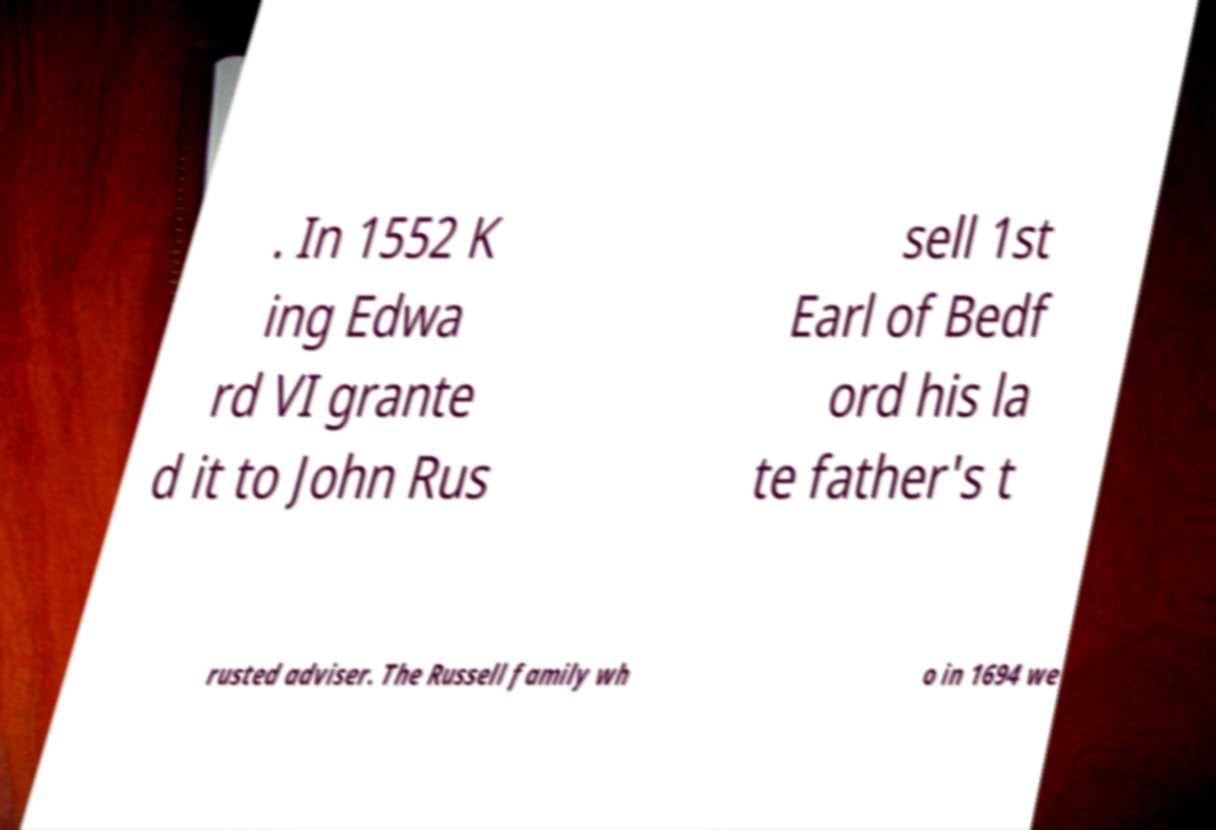Could you extract and type out the text from this image? . In 1552 K ing Edwa rd VI grante d it to John Rus sell 1st Earl of Bedf ord his la te father's t rusted adviser. The Russell family wh o in 1694 we 